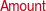Convert chart to OTSL. <chart><loc_0><loc_0><loc_500><loc_500><pie_chart><fcel>Weighted Average Interest Rate<fcel>Amount<nl><fcel>100.0%<fcel>0.0%<nl></chart> 